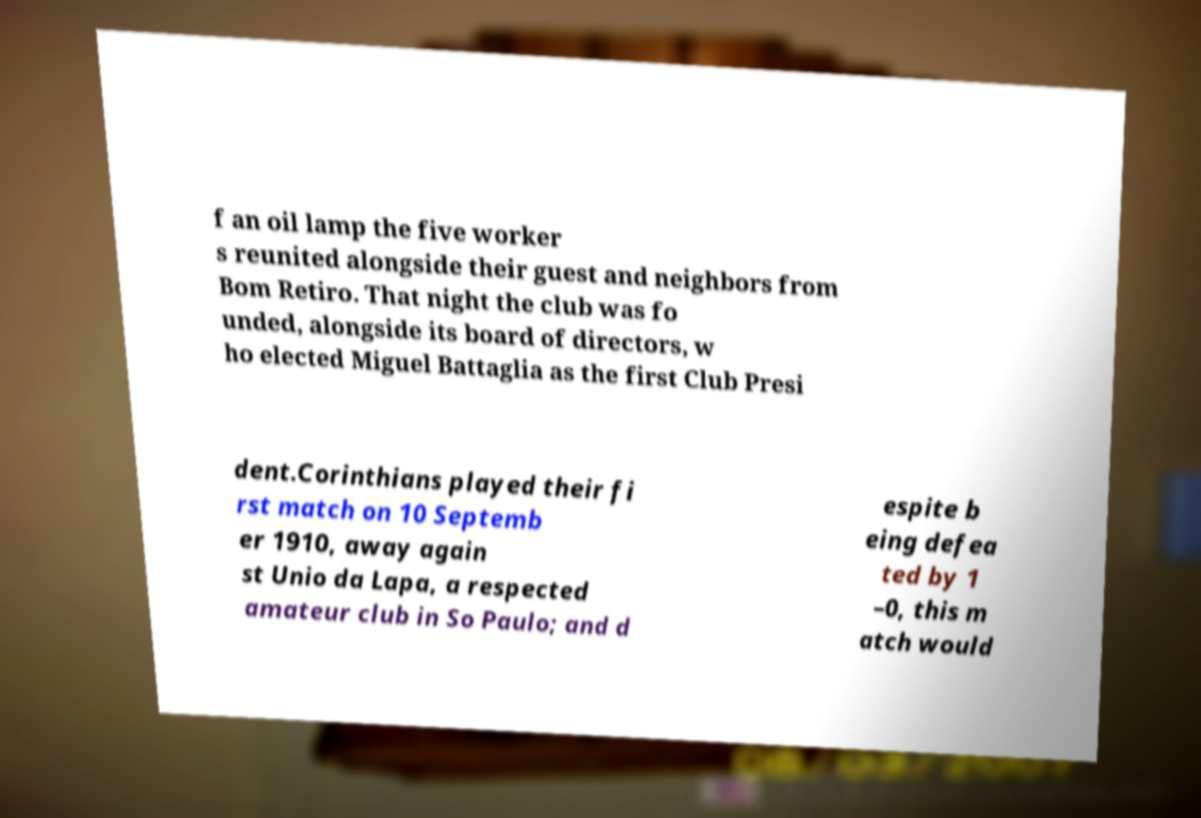Please identify and transcribe the text found in this image. f an oil lamp the five worker s reunited alongside their guest and neighbors from Bom Retiro. That night the club was fo unded, alongside its board of directors, w ho elected Miguel Battaglia as the first Club Presi dent.Corinthians played their fi rst match on 10 Septemb er 1910, away again st Unio da Lapa, a respected amateur club in So Paulo; and d espite b eing defea ted by 1 –0, this m atch would 